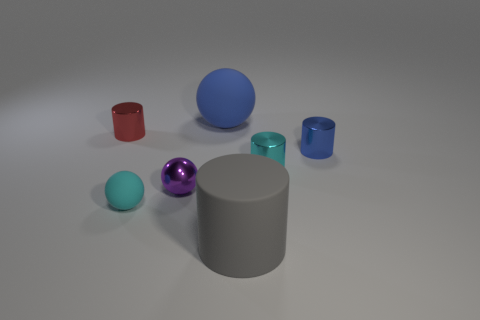Add 2 big gray matte cylinders. How many objects exist? 9 Subtract all cylinders. How many objects are left? 3 Subtract 1 cyan cylinders. How many objects are left? 6 Subtract all matte cylinders. Subtract all yellow metallic balls. How many objects are left? 6 Add 6 purple metallic balls. How many purple metallic balls are left? 7 Add 2 gray matte cubes. How many gray matte cubes exist? 2 